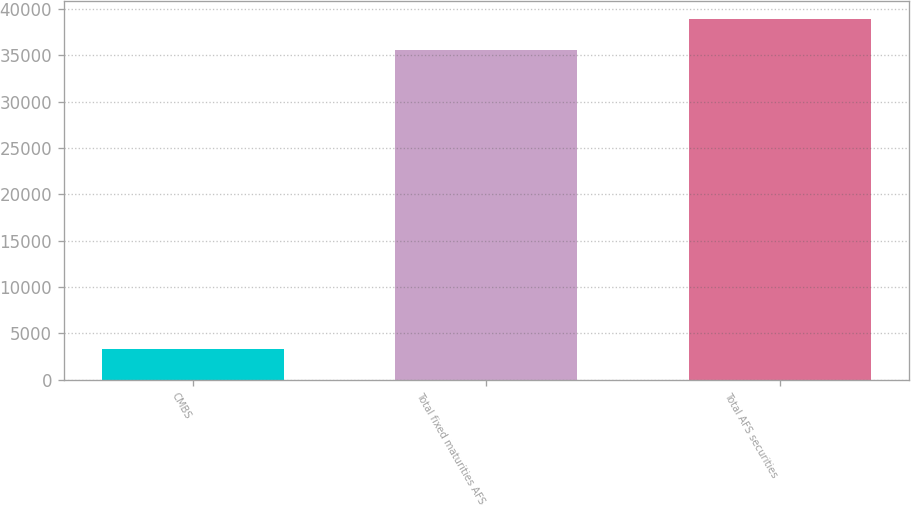Convert chart to OTSL. <chart><loc_0><loc_0><loc_500><loc_500><bar_chart><fcel>CMBS<fcel>Total fixed maturities AFS<fcel>Total AFS securities<nl><fcel>3304<fcel>35612<fcel>38933.5<nl></chart> 